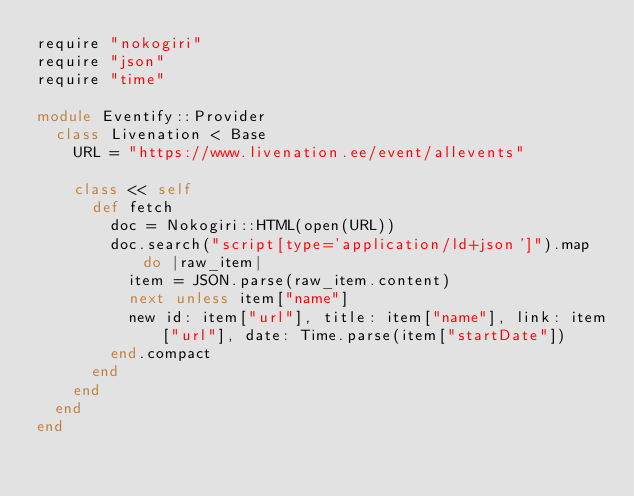<code> <loc_0><loc_0><loc_500><loc_500><_Ruby_>require "nokogiri"
require "json"
require "time"

module Eventify::Provider
  class Livenation < Base
    URL = "https://www.livenation.ee/event/allevents" 

    class << self
      def fetch
        doc = Nokogiri::HTML(open(URL))
        doc.search("script[type='application/ld+json']").map do |raw_item|
          item = JSON.parse(raw_item.content)
          next unless item["name"]
          new id: item["url"], title: item["name"], link: item["url"], date: Time.parse(item["startDate"])
        end.compact
      end
    end
  end
end
</code> 